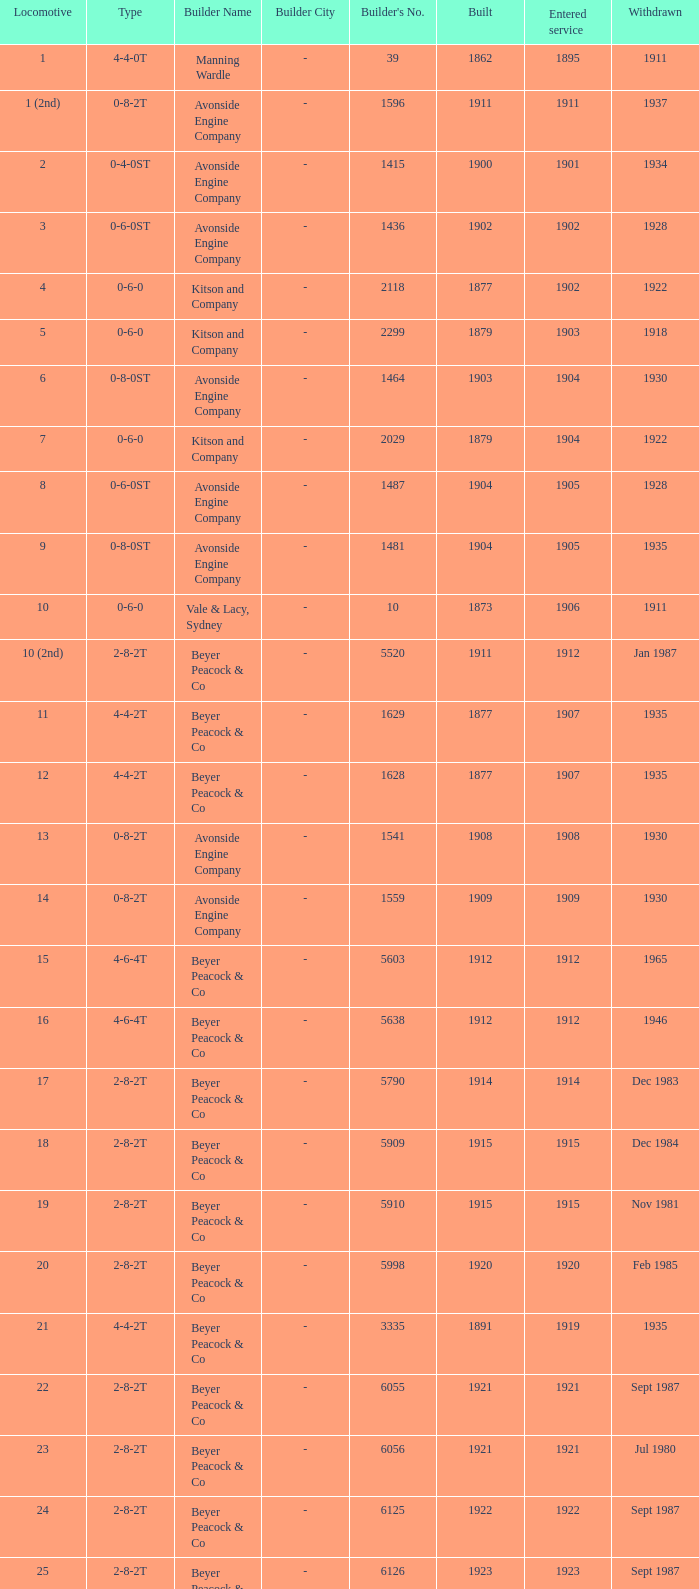Which locomotive had a 2-8-2t type, entered service year prior to 1915, and which was built after 1911? 17.0. 